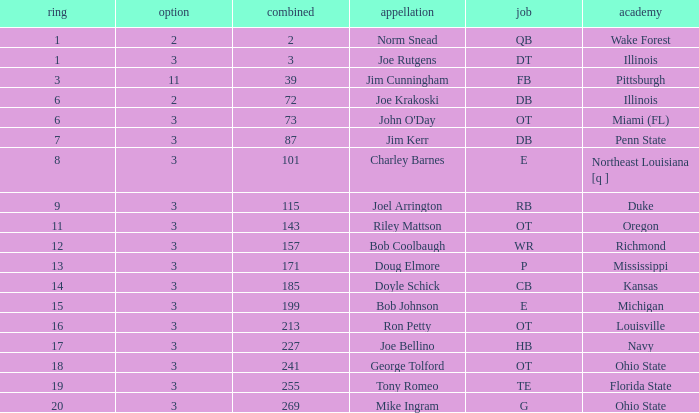How many rounds have john o'day as the name, and a pick less than 3? None. 